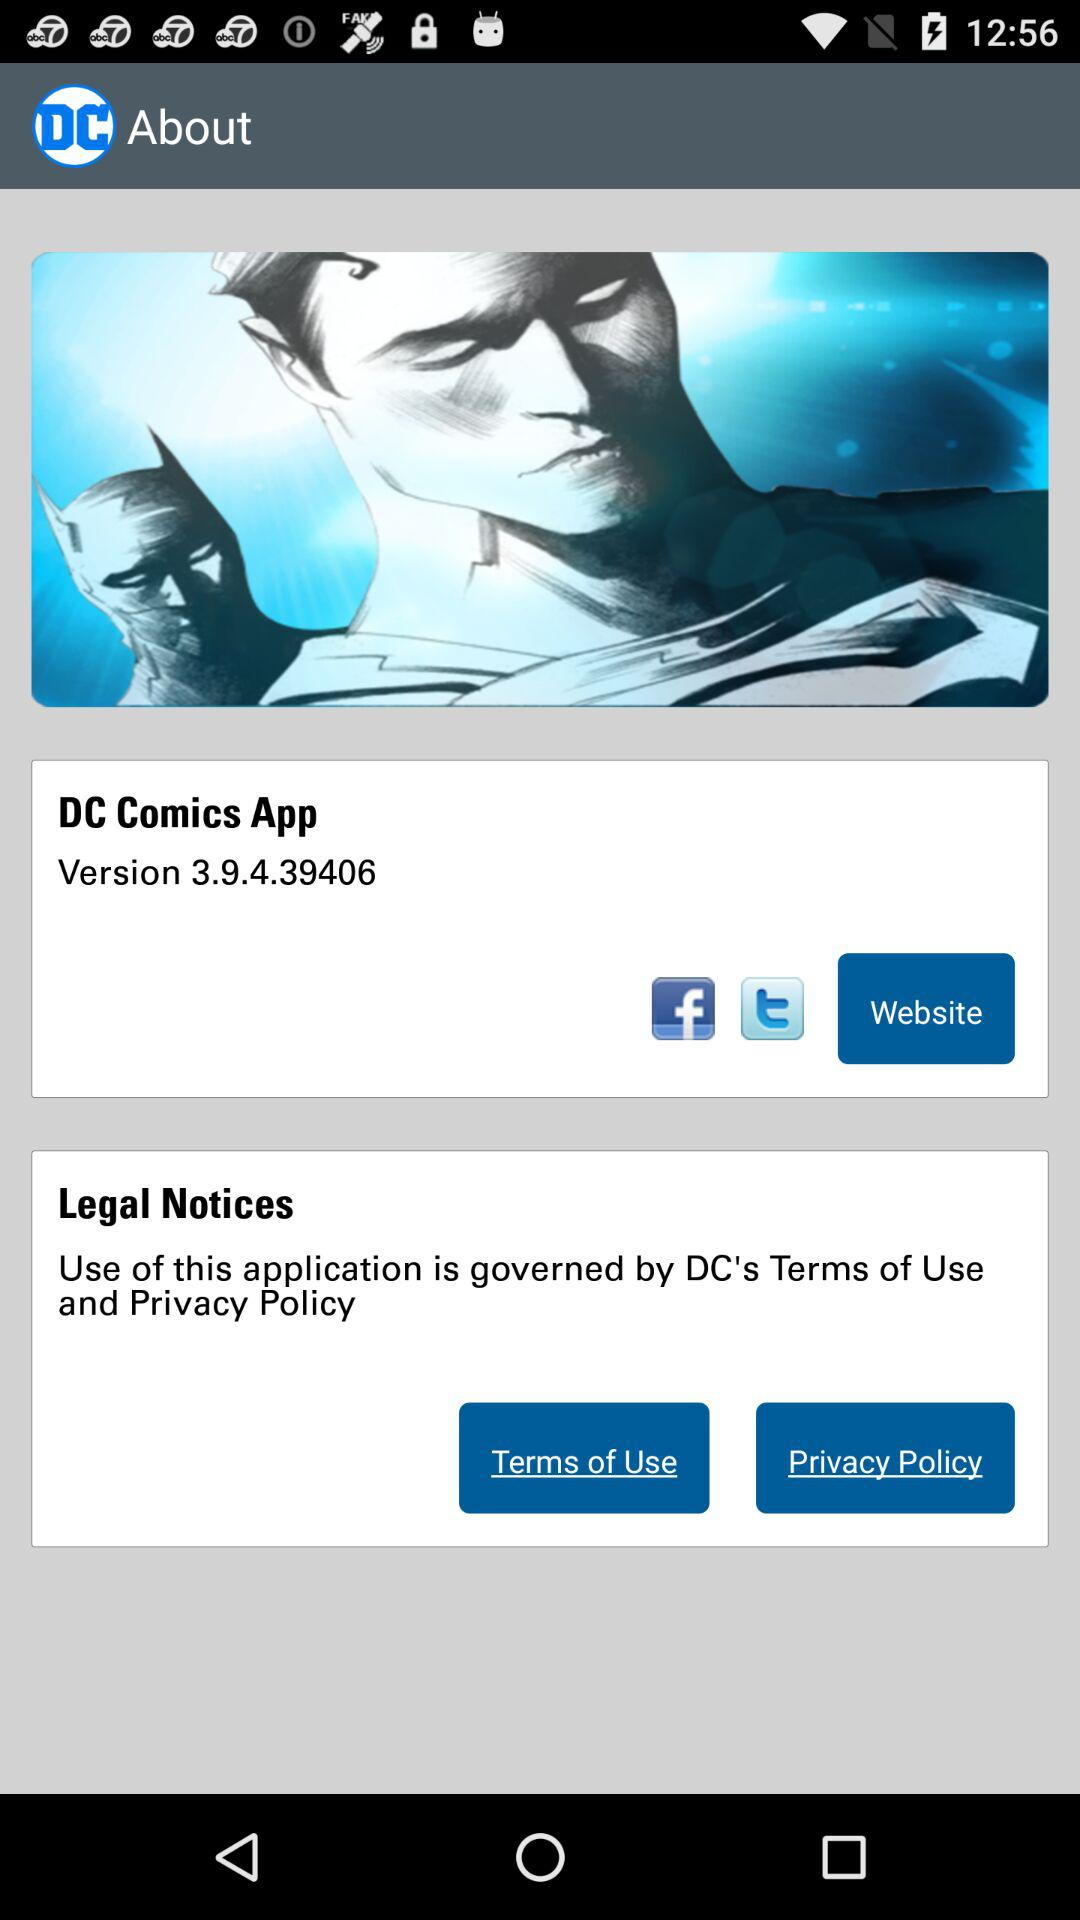What is the version of the "DC Comics" app? The version is 3.9.4.39406. 